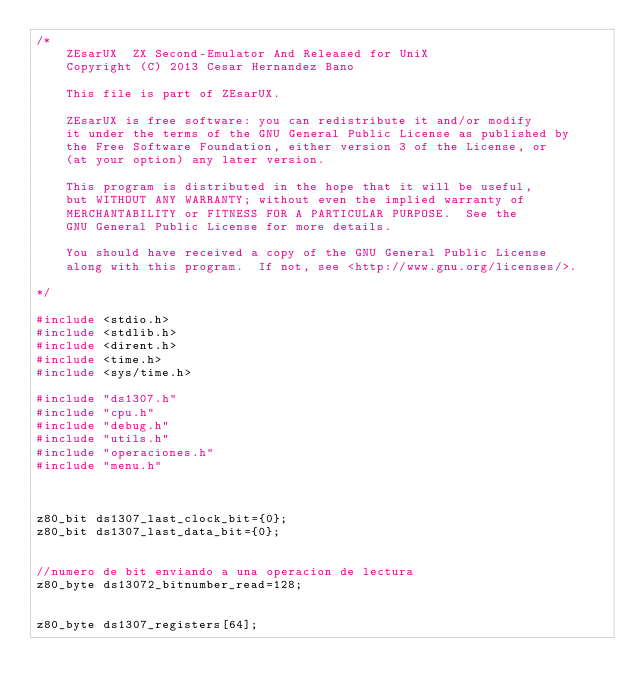Convert code to text. <code><loc_0><loc_0><loc_500><loc_500><_C_>/*
    ZEsarUX  ZX Second-Emulator And Released for UniX
    Copyright (C) 2013 Cesar Hernandez Bano

    This file is part of ZEsarUX.

    ZEsarUX is free software: you can redistribute it and/or modify
    it under the terms of the GNU General Public License as published by
    the Free Software Foundation, either version 3 of the License, or
    (at your option) any later version.

    This program is distributed in the hope that it will be useful,
    but WITHOUT ANY WARRANTY; without even the implied warranty of
    MERCHANTABILITY or FITNESS FOR A PARTICULAR PURPOSE.  See the
    GNU General Public License for more details.

    You should have received a copy of the GNU General Public License
    along with this program.  If not, see <http://www.gnu.org/licenses/>.

*/

#include <stdio.h>
#include <stdlib.h>
#include <dirent.h>
#include <time.h>
#include <sys/time.h>

#include "ds1307.h"
#include "cpu.h"
#include "debug.h"
#include "utils.h"
#include "operaciones.h"
#include "menu.h"



z80_bit ds1307_last_clock_bit={0};
z80_bit ds1307_last_data_bit={0};


//numero de bit enviando a una operacion de lectura
z80_byte ds13072_bitnumber_read=128;


z80_byte ds1307_registers[64];
</code> 